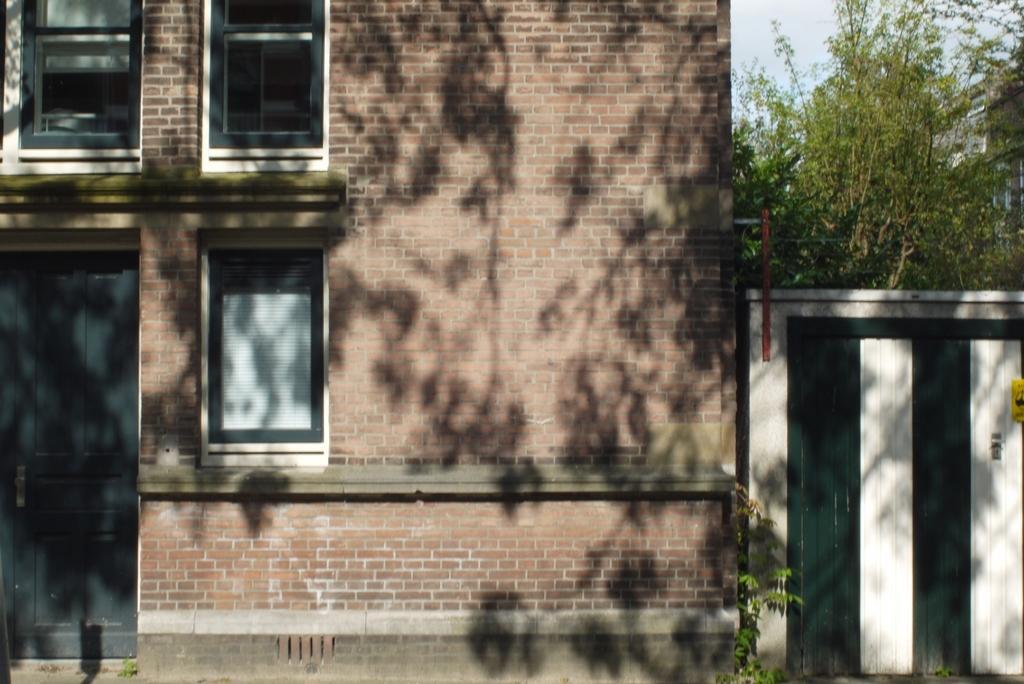Please provide a concise description of this image. In this image I see the buildings on which I see the windows and I see door over here and I see the fencing over here and I see plants, trees and the sky. 